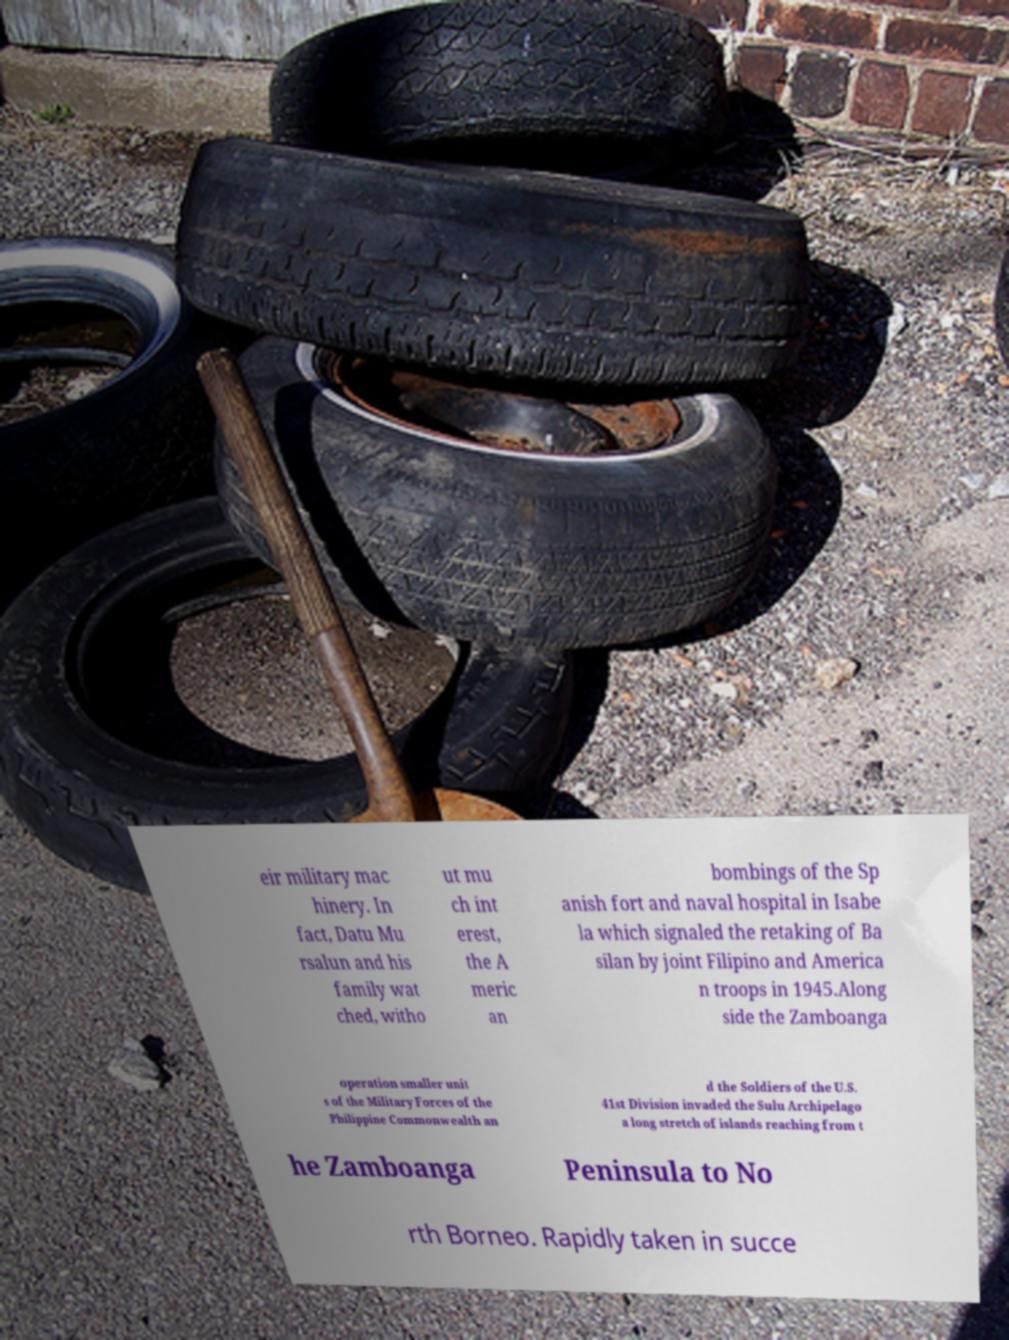What messages or text are displayed in this image? I need them in a readable, typed format. eir military mac hinery. In fact, Datu Mu rsalun and his family wat ched, witho ut mu ch int erest, the A meric an bombings of the Sp anish fort and naval hospital in Isabe la which signaled the retaking of Ba silan by joint Filipino and America n troops in 1945.Along side the Zamboanga operation smaller unit s of the Military Forces of the Philippine Commonwealth an d the Soldiers of the U.S. 41st Division invaded the Sulu Archipelago a long stretch of islands reaching from t he Zamboanga Peninsula to No rth Borneo. Rapidly taken in succe 